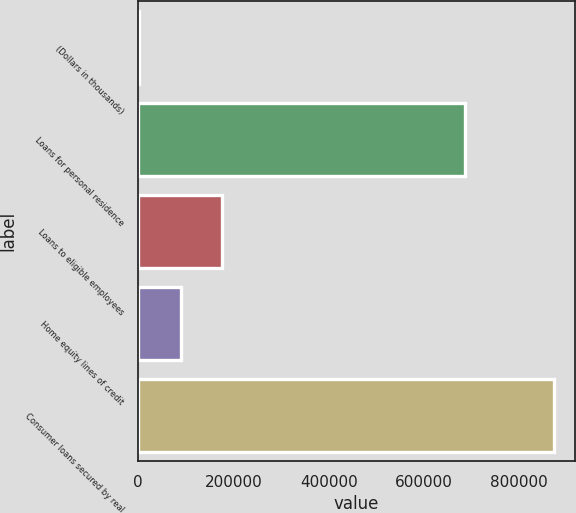<chart> <loc_0><loc_0><loc_500><loc_500><bar_chart><fcel>(Dollars in thousands)<fcel>Loans for personal residence<fcel>Loans to eligible employees<fcel>Home equity lines of credit<fcel>Consumer loans secured by real<nl><fcel>2013<fcel>685327<fcel>176261<fcel>89137.2<fcel>873255<nl></chart> 